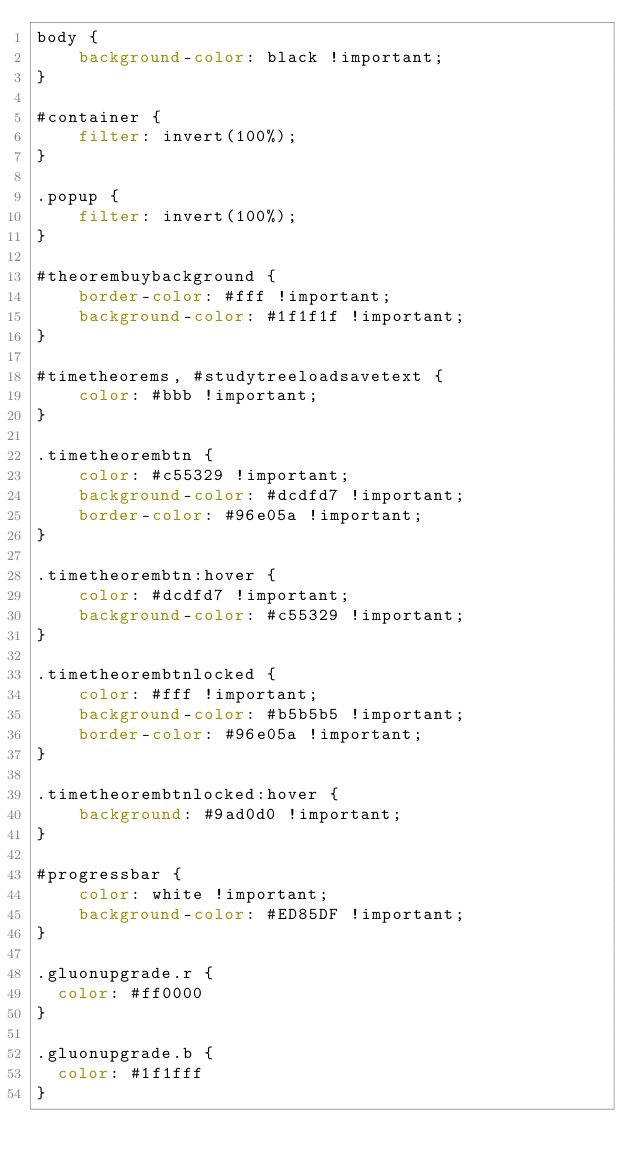Convert code to text. <code><loc_0><loc_0><loc_500><loc_500><_CSS_>body {
    background-color: black !important;
}

#container {
    filter: invert(100%);
}

.popup {
    filter: invert(100%);
}

#theorembuybackground {
    border-color: #fff !important;
    background-color: #1f1f1f !important;
}

#timetheorems, #studytreeloadsavetext {
    color: #bbb !important;
}

.timetheorembtn {
    color: #c55329 !important;
    background-color: #dcdfd7 !important;
    border-color: #96e05a !important;
}

.timetheorembtn:hover {
    color: #dcdfd7 !important;
    background-color: #c55329 !important;
}

.timetheorembtnlocked {
    color: #fff !important;
    background-color: #b5b5b5 !important;
    border-color: #96e05a !important;
}

.timetheorembtnlocked:hover {
    background: #9ad0d0 !important;
}

#progressbar {
    color: white !important;
    background-color: #ED85DF !important;
}

.gluonupgrade.r {
	color: #ff0000
}

.gluonupgrade.b {
	color: #1f1fff
}</code> 